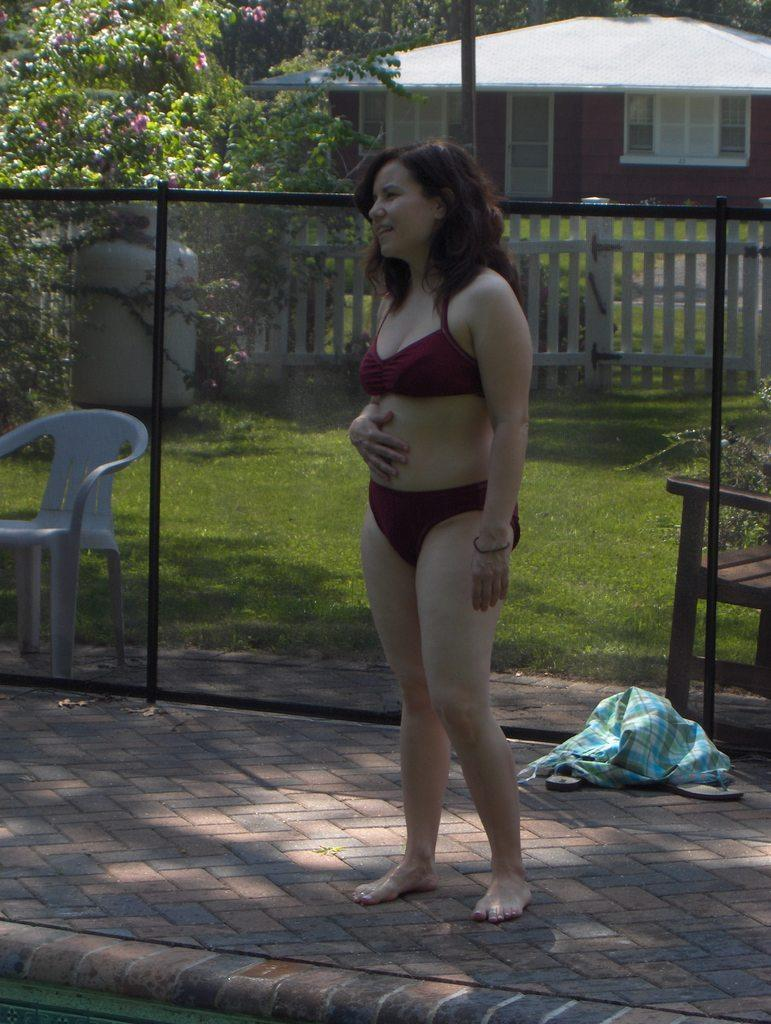What is the person in the image wearing? The person is wearing a bikini in the image. Where is the person standing in the image? The person is standing on the floor in the image. What can be seen in the background of the image? There is a house, trees, a lawn, and a chair in the background of the image. What type of instrument is the person playing in the image? There is no instrument present in the image; the person is wearing a bikini and standing on the floor. What event is taking place in the image? The image does not depict a specific event; it shows a person wearing a bikini and standing on the floor with a background of a house, trees, a lawn, and a chair. 